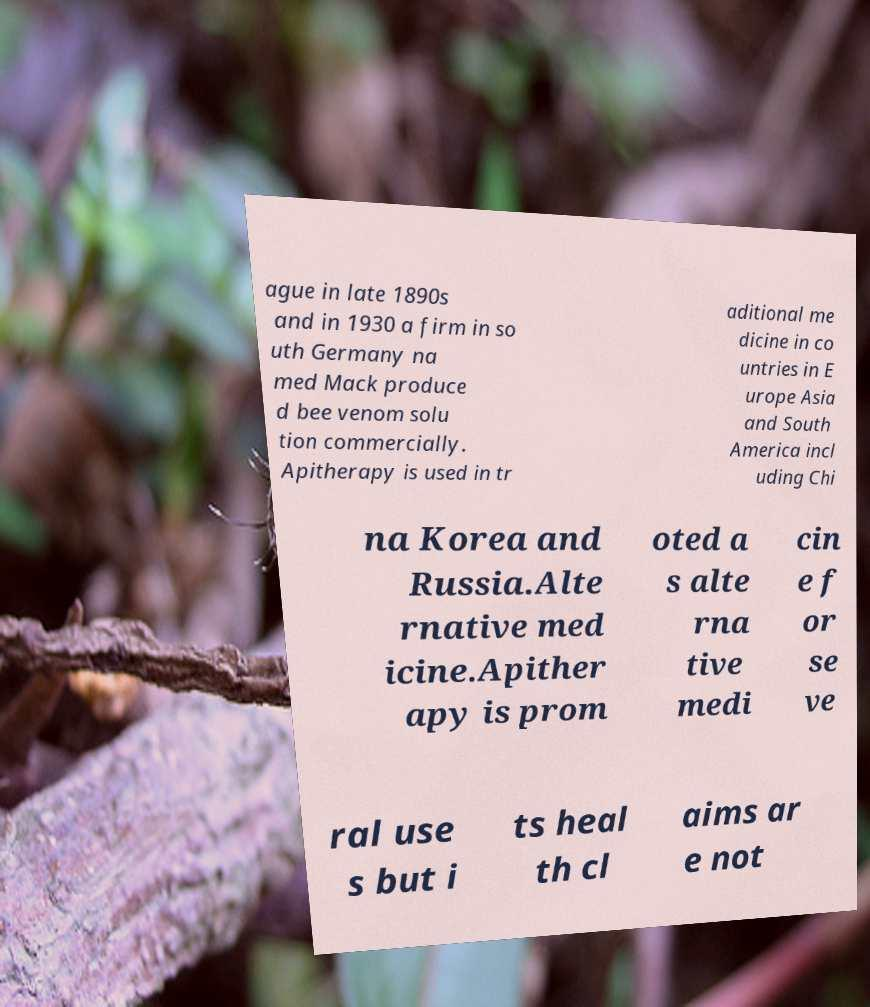Can you accurately transcribe the text from the provided image for me? ague in late 1890s and in 1930 a firm in so uth Germany na med Mack produce d bee venom solu tion commercially. Apitherapy is used in tr aditional me dicine in co untries in E urope Asia and South America incl uding Chi na Korea and Russia.Alte rnative med icine.Apither apy is prom oted a s alte rna tive medi cin e f or se ve ral use s but i ts heal th cl aims ar e not 